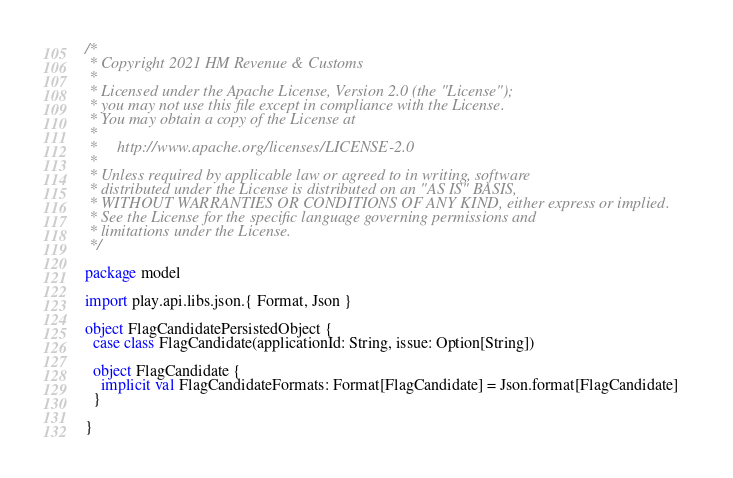Convert code to text. <code><loc_0><loc_0><loc_500><loc_500><_Scala_>/*
 * Copyright 2021 HM Revenue & Customs
 *
 * Licensed under the Apache License, Version 2.0 (the "License");
 * you may not use this file except in compliance with the License.
 * You may obtain a copy of the License at
 *
 *     http://www.apache.org/licenses/LICENSE-2.0
 *
 * Unless required by applicable law or agreed to in writing, software
 * distributed under the License is distributed on an "AS IS" BASIS,
 * WITHOUT WARRANTIES OR CONDITIONS OF ANY KIND, either express or implied.
 * See the License for the specific language governing permissions and
 * limitations under the License.
 */

package model

import play.api.libs.json.{ Format, Json }

object FlagCandidatePersistedObject {
  case class FlagCandidate(applicationId: String, issue: Option[String])

  object FlagCandidate {
    implicit val FlagCandidateFormats: Format[FlagCandidate] = Json.format[FlagCandidate]
  }

}
</code> 